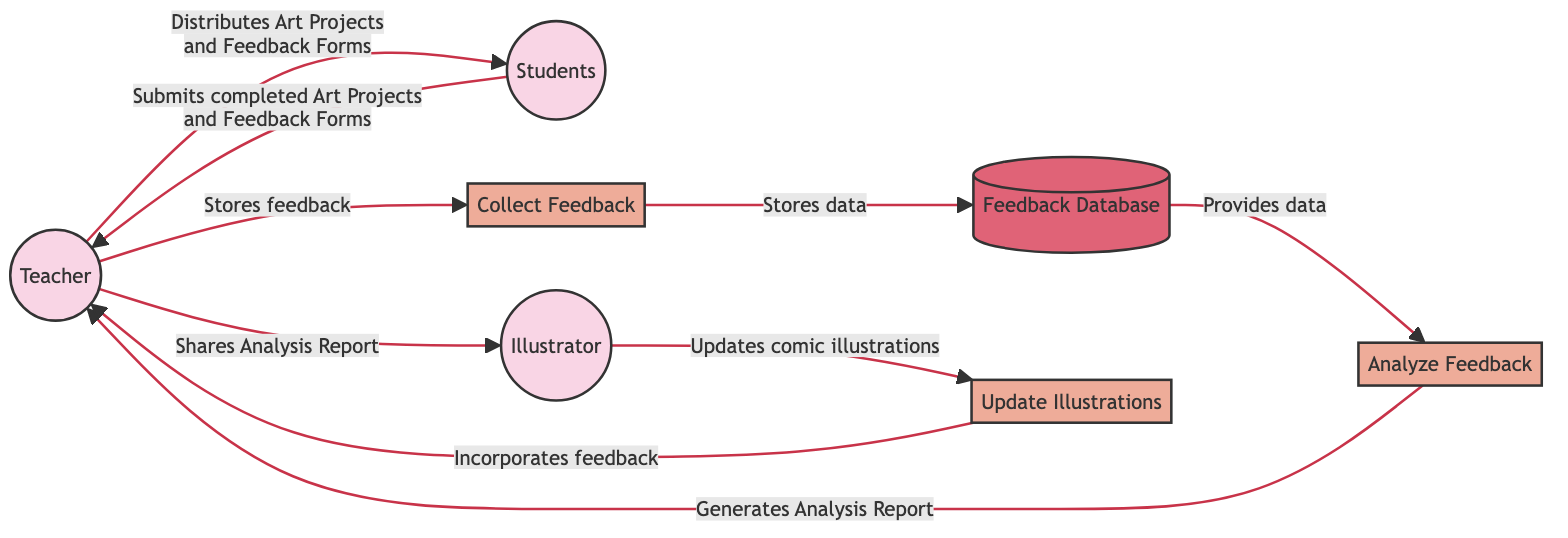What is the first action taken by the Teacher? The first action taken by the Teacher is to distribute Art Projects and Feedback Forms to the Students. This is indicated by the arrow pointing from Teacher to Students labeled with this description.
Answer: Distributes Art Projects and Feedback Forms How many entities are in the diagram? In the diagram, there are a total of seven entities: Teacher, Students, Illustrator, Art Projects, Feedback Form, Feedback Database, and Analysis Report. Counting these provides the answer.
Answer: Seven What does the Teacher do after receiving feedback from Students? After receiving feedback from Students, the Teacher submits the data to the Collect Feedback process to store the feedback in the Feedback Database. This sequence is traced through the arrows connecting the nodes.
Answer: Stores feedback Who receives the Analysis Report from the Teacher? The Analysis Report generated by the Analyze Feedback process is shared with the Illustrator by the Teacher. This is shown in the flow connecting the Teacher to the Illustrator.
Answer: Illustrator What is the role of the Feedback Database in this diagram? The Feedback Database acts as a data store where all collected feedback is stored, and it also provides data for the Analyze Feedback process. Both roles are represented in the connections to and from this entity.
Answer: Stores feedback What process does the Illustrator undertake after receiving the Analysis Report? After receiving the Analysis Report, the Illustrator updates comic illustrations based on the feedback provided. This is detailed in the directed flow from the Illustrator to the Update Illustrations process.
Answer: Updates comic illustrations Which two processes are performed by the Teacher? The two processes performed by the Teacher are Collect Feedback and Analyze Feedback. This is evident from the arrows leading to and from the Teacher indicating these specific processes.
Answer: Collect Feedback and Analyze Feedback What is the final action resulting from the Update Illustrations process? The final action resulting from the Update Illustrations process is the incorporation of feedback back to the Teacher. This is captured by the flow from Update Illustrations back to Teacher.
Answer: Incorporates feedback 